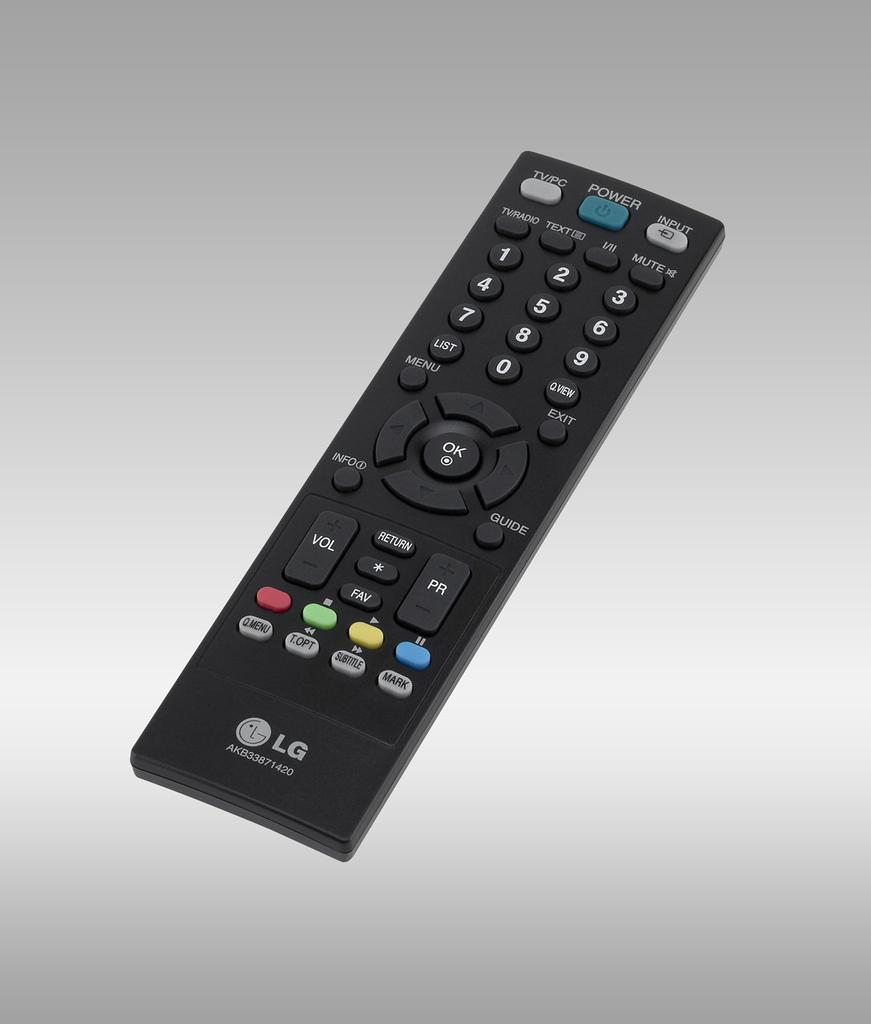<image>
Share a concise interpretation of the image provided. Long and black remote LG controller with the power button near the top. 